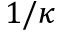Convert formula to latex. <formula><loc_0><loc_0><loc_500><loc_500>1 / \kappa</formula> 